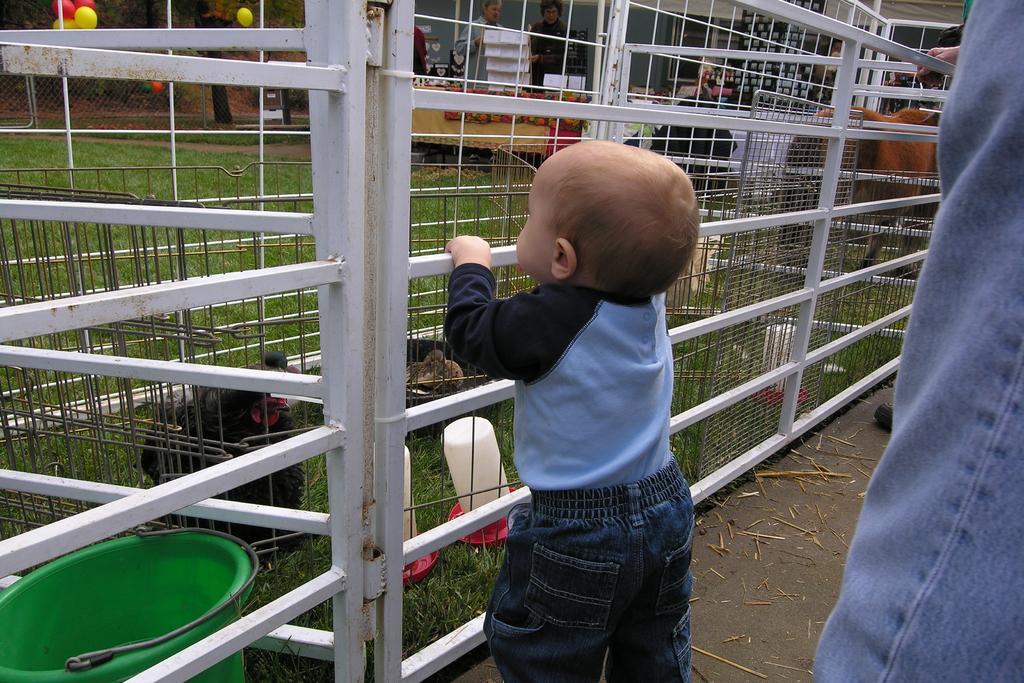In one or two sentences, can you explain what this image depicts? In the center of the image there is a child staring the hens which are on the grill. Beside the grill there is a horse. In the background of the image there is a metal fence and we can see the balloons. At the backside of the image there are people standing in front of the table and on top of it there are few objects. 